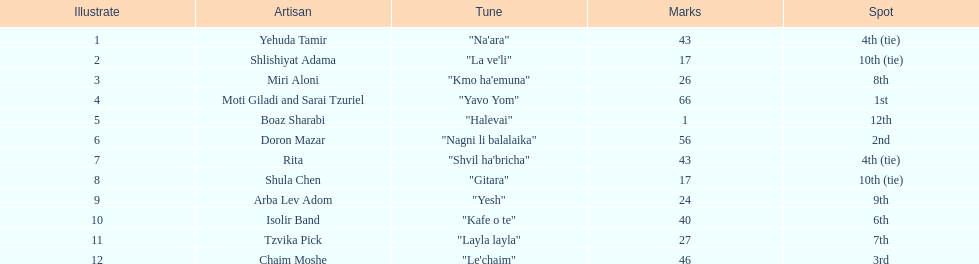What are the points? 43, 17, 26, 66, 1, 56, 43, 17, 24, 40, 27, 46. What is the least? 1. Which artist has that much Boaz Sharabi. 